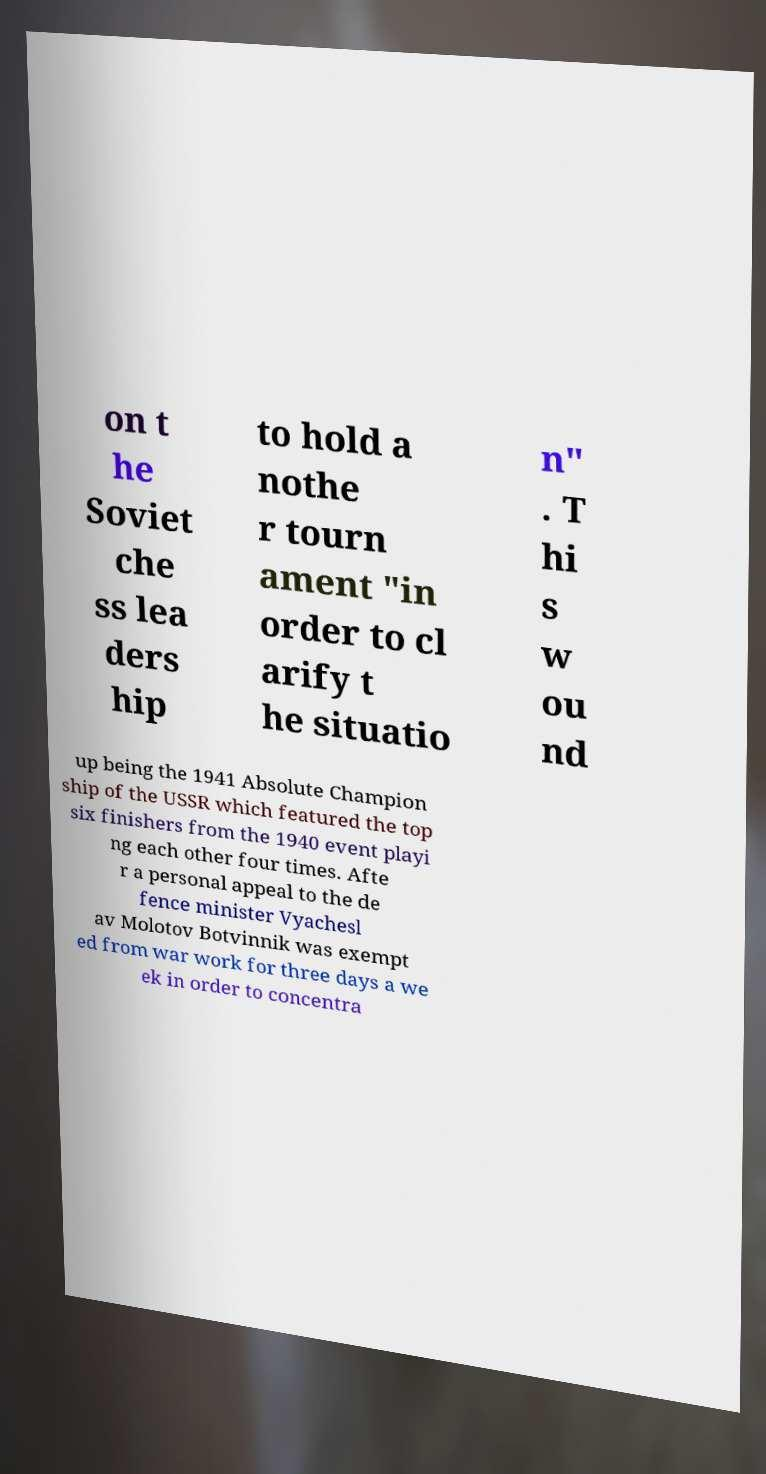I need the written content from this picture converted into text. Can you do that? on t he Soviet che ss lea ders hip to hold a nothe r tourn ament "in order to cl arify t he situatio n" . T hi s w ou nd up being the 1941 Absolute Champion ship of the USSR which featured the top six finishers from the 1940 event playi ng each other four times. Afte r a personal appeal to the de fence minister Vyachesl av Molotov Botvinnik was exempt ed from war work for three days a we ek in order to concentra 